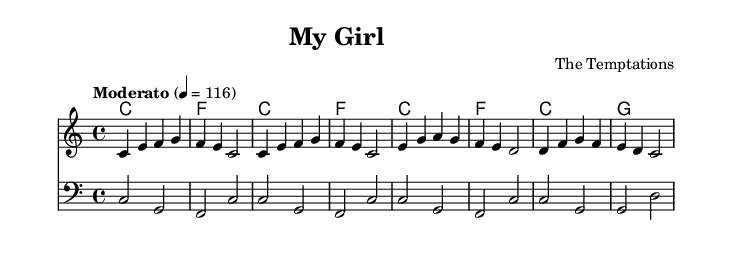What is the key signature of this music? The key signature is indicated at the beginning of the staff and shows C major, which has no sharps or flats.
Answer: C major What is the time signature of this music? The time signature is found at the beginning of the score, indicating that the piece is in 4/4 time, meaning there are four beats per measure.
Answer: 4/4 What is the tempo marking for this piece? The tempo marking is written in Italian as "Moderato," with a metronome marking given as 4 = 116, which means play at a moderate speed of 116 beats per minute.
Answer: Moderato 4 = 116 How many measures are there in the melody? By counting the measures in the melody section, we find there are 8 measures total in the provided melody line.
Answer: 8 What is the chord progression in the first four measures? The chord progression can be observed in the harmonies section, which shows C major to F major to C major to F major in the first four measures.
Answer: C, F, C, F Which voice plays the bass line? The bass line is indicated below the melody and is identified as being played in the bass clef, specifically noted as "bass" in the staff.
Answer: Bass What genre does this music represent? This music is identified by its soulful characteristics and connection to the Motown sound, which fits within the rhythm and blues genre.
Answer: Rhythm and blues 